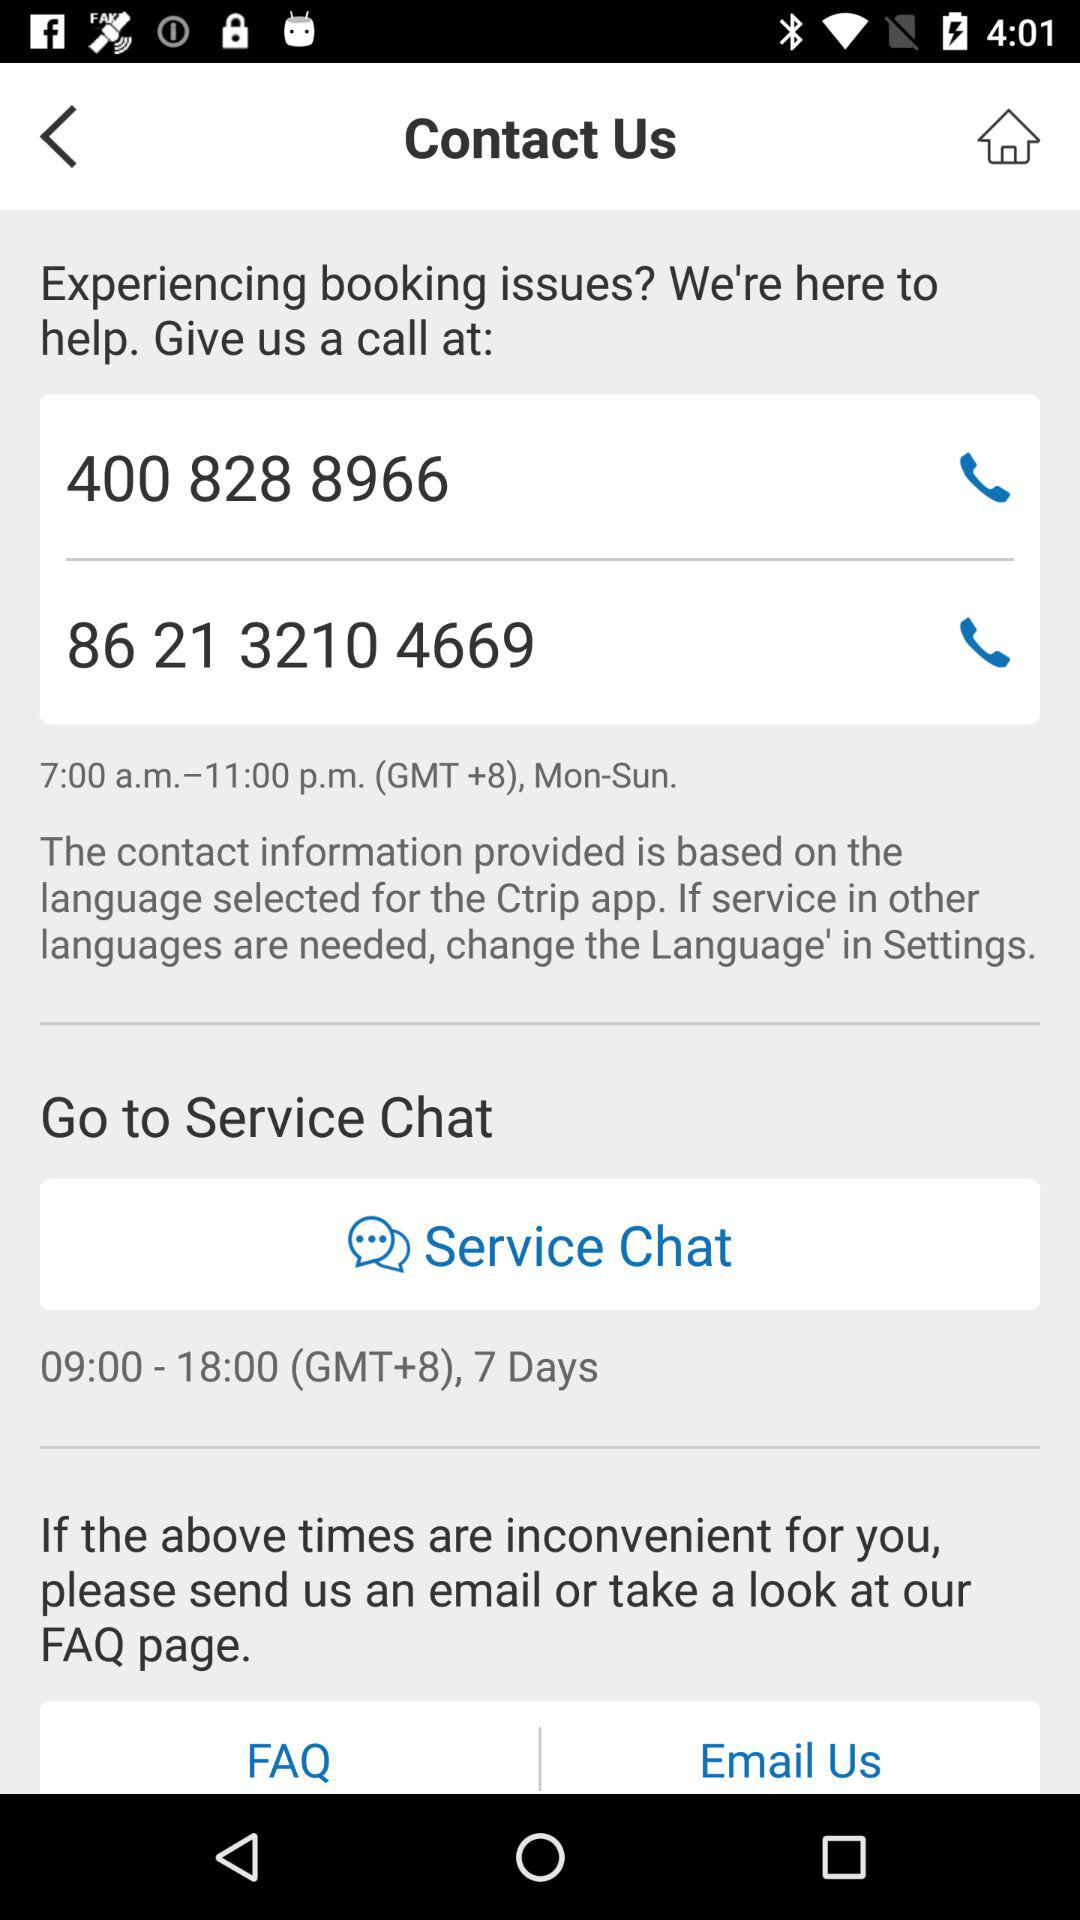What are the hours of operation for the service chat?
Answer the question using a single word or phrase. 09:00 - 18:00 (GMT+8), 7 Days 